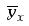Convert formula to latex. <formula><loc_0><loc_0><loc_500><loc_500>\overline { y } _ { x }</formula> 